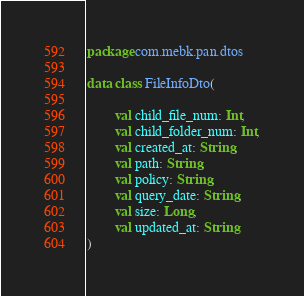<code> <loc_0><loc_0><loc_500><loc_500><_Kotlin_>package com.mebk.pan.dtos

data class FileInfoDto(

        val child_file_num: Int,
        val child_folder_num: Int,
        val created_at: String,
        val path: String,
        val policy: String,
        val query_date: String,
        val size: Long,
        val updated_at: String
)
</code> 